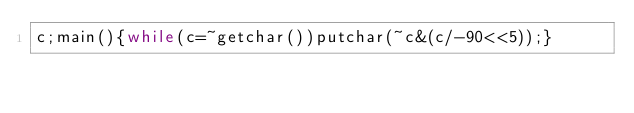Convert code to text. <code><loc_0><loc_0><loc_500><loc_500><_C_>c;main(){while(c=~getchar())putchar(~c&(c/-90<<5));}</code> 